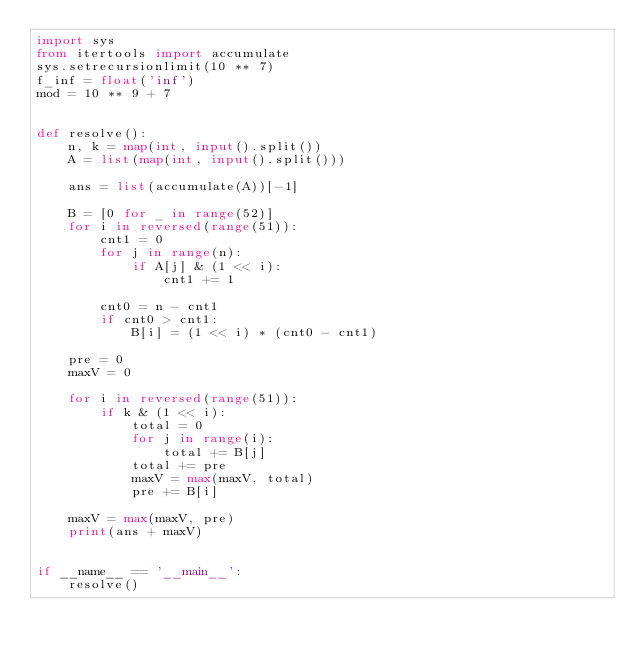<code> <loc_0><loc_0><loc_500><loc_500><_Python_>import sys
from itertools import accumulate
sys.setrecursionlimit(10 ** 7)
f_inf = float('inf')
mod = 10 ** 9 + 7


def resolve():
    n, k = map(int, input().split())
    A = list(map(int, input().split()))

    ans = list(accumulate(A))[-1]

    B = [0 for _ in range(52)]
    for i in reversed(range(51)):
        cnt1 = 0
        for j in range(n):
            if A[j] & (1 << i):
                cnt1 += 1

        cnt0 = n - cnt1
        if cnt0 > cnt1:
            B[i] = (1 << i) * (cnt0 - cnt1)

    pre = 0
    maxV = 0

    for i in reversed(range(51)):
        if k & (1 << i):
            total = 0
            for j in range(i):
                total += B[j]
            total += pre
            maxV = max(maxV, total)
            pre += B[i]

    maxV = max(maxV, pre)
    print(ans + maxV)


if __name__ == '__main__':
    resolve()
</code> 